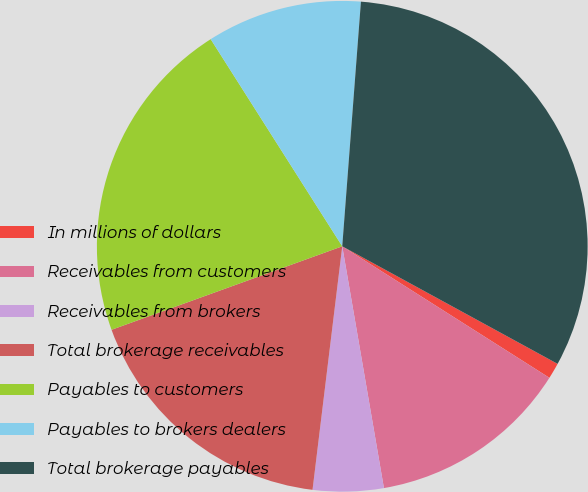Convert chart. <chart><loc_0><loc_0><loc_500><loc_500><pie_chart><fcel>In millions of dollars<fcel>Receivables from customers<fcel>Receivables from brokers<fcel>Total brokerage receivables<fcel>Payables to customers<fcel>Payables to brokers dealers<fcel>Total brokerage payables<nl><fcel>1.05%<fcel>13.28%<fcel>4.65%<fcel>17.54%<fcel>21.52%<fcel>10.22%<fcel>31.74%<nl></chart> 